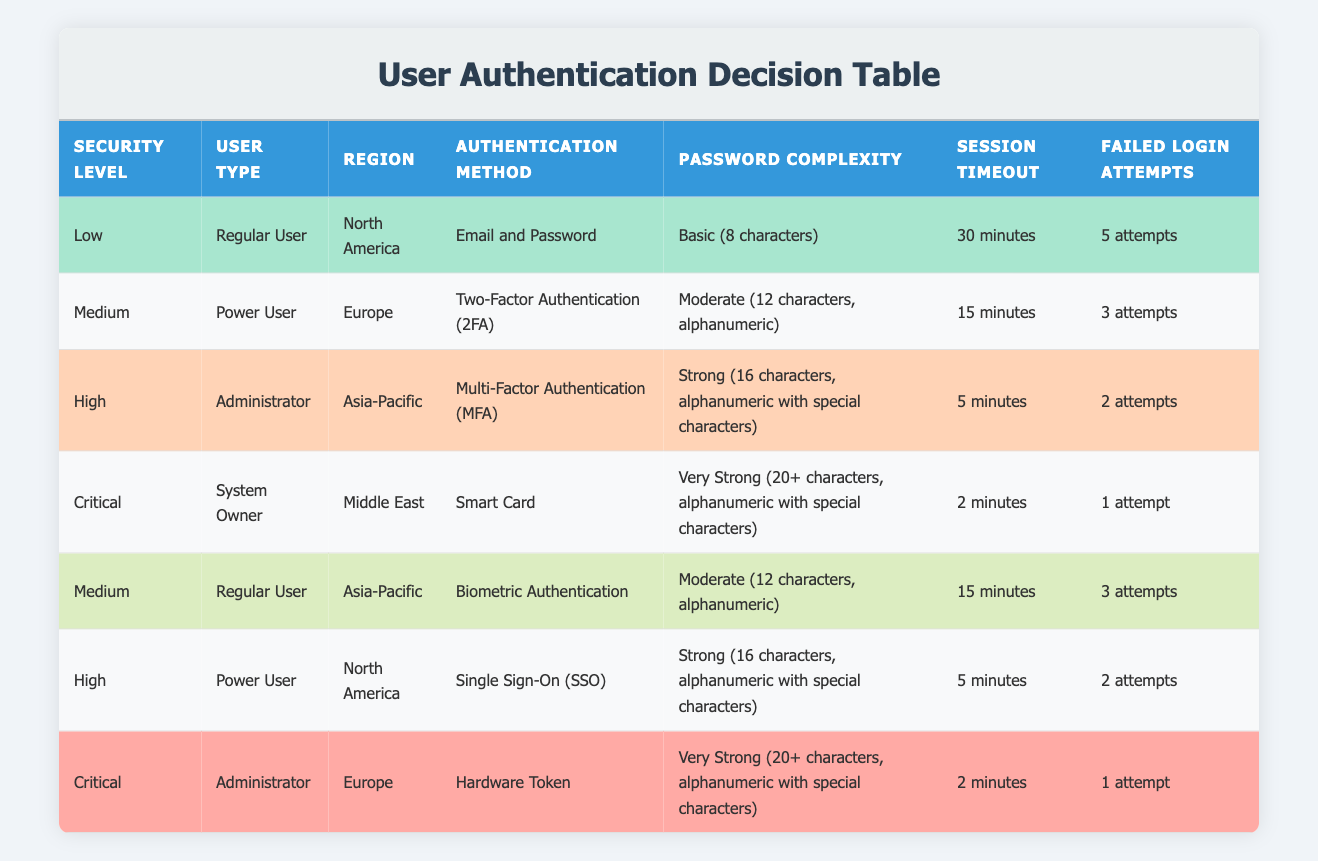What is the authentication method for a Regular User in North America with Low security level? From the table, we can see that the entry for Low security level, Regular User, and North America specifies "Email and Password" as the authentication method.
Answer: Email and Password Which region requires Smart Card authentication for the System Owner with Critical security level? According to the table, the entry for Critical security level shows that a System Owner in the Middle East is required to use Smart Card authentication.
Answer: Middle East What is the password complexity for an Administrator in the Asia-Pacific region with High security level? The table shows that for High security level and Administrator in Asia-Pacific, the password complexity is "Strong (16 characters, alphanumeric with special characters)."
Answer: Strong (16 characters, alphanumeric with special characters) Is Two-Factor Authentication (2FA) used for a Regular User in Europe under Medium security level? Checking the table, it indicates that Two-Factor Authentication (2FA) is not utilized for Regular Users in Europe. It is instead used for Power Users in that region. Thus, the statement is false.
Answer: No What is the session timeout for Critical security level and which user type is it assigned to? Referring to the table, Critical security level has a session timeout of "2 minutes," and it is assigned to a System Owner.
Answer: 2 minutes; System Owner Identify the user type that has a maximum of 3 failed login attempts in Europe. The table shows that for users in Europe, a Power User with Medium security level has a limit of 3 failed login attempts, while an Administrator at Critical security has only 1 attempt. The first matches the criteria for the maximum.
Answer: Power User How do the password complexities differ between Regular Users in North America and Asia-Pacific under Medium security level? In the table, Regular Users in North America under Low security level have a password complexity of "Basic (8 characters)," while Regular Users in Asia-Pacific under Medium security level have "Moderate (12 characters, alphanumeric)." The difference is that one is basic while the other is moderate.
Answer: Basic vs. Moderate Which authentication methods have the strongest password complexity, and which user types and regions do they belong to? The strongest password complexity is categorized as "Very Strong (20+ characters, alphanumeric with special characters)," which is associated with the Critical security level for System Owner in the Middle East using Smart Card, and for Administrator in Europe using Hardware Token.
Answer: Smart Card; System Owner; Middle East and Hardware Token; Administrator; Europe 